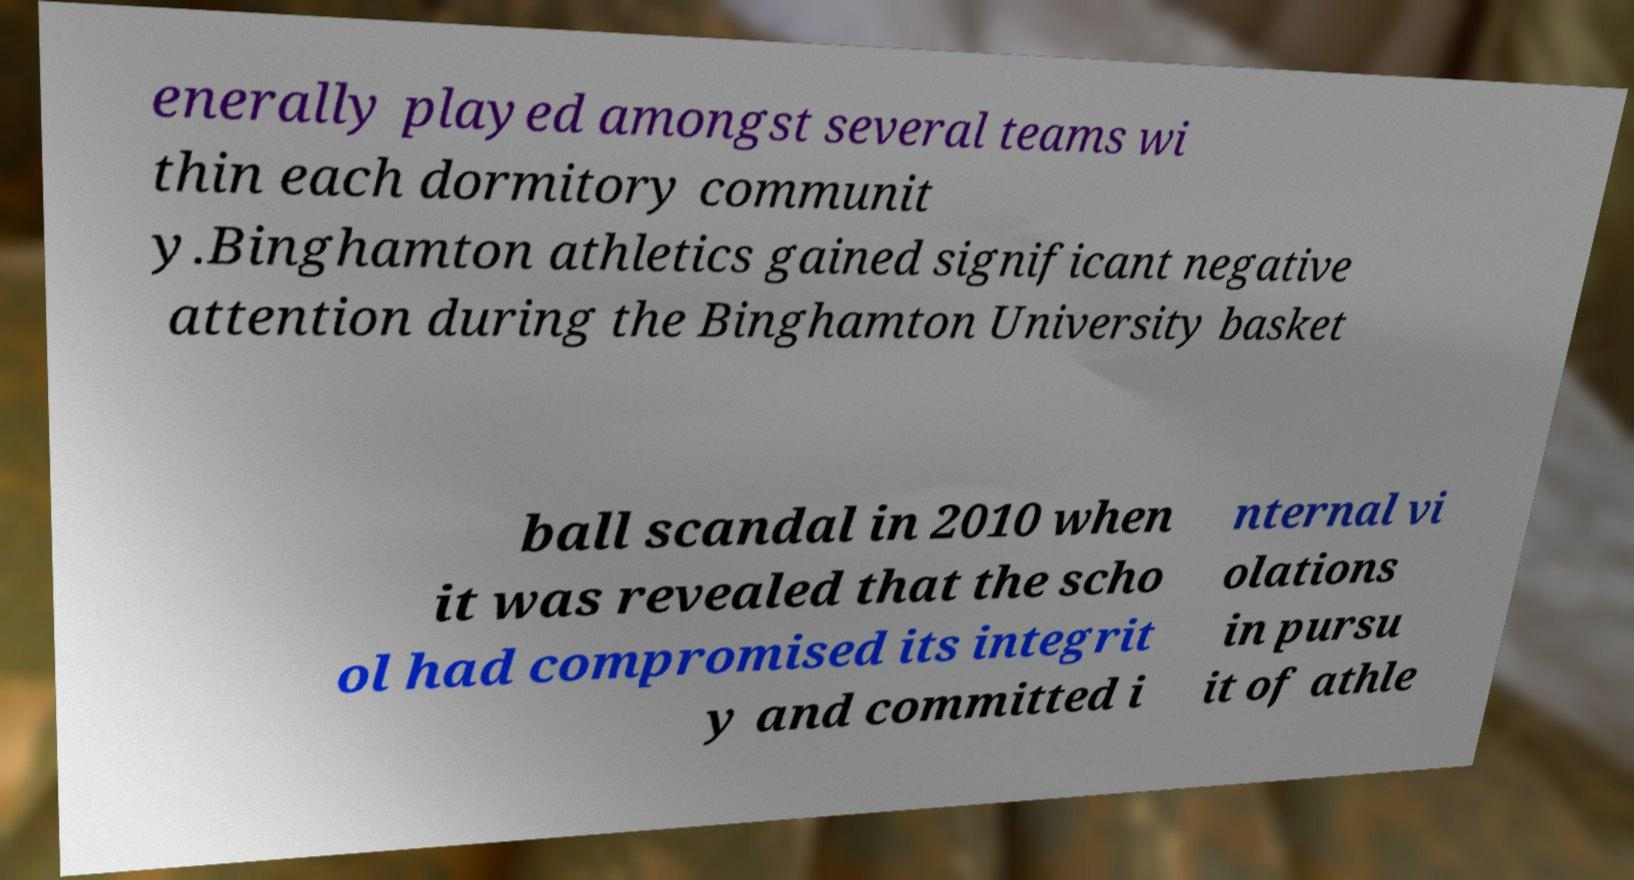What messages or text are displayed in this image? I need them in a readable, typed format. enerally played amongst several teams wi thin each dormitory communit y.Binghamton athletics gained significant negative attention during the Binghamton University basket ball scandal in 2010 when it was revealed that the scho ol had compromised its integrit y and committed i nternal vi olations in pursu it of athle 